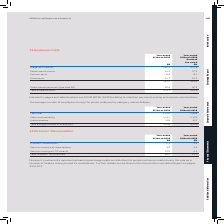According to Sophos Group's financial document, What was included in wages and salaries? $4.2M (2018: $4.0M) relating to retention payments arising on business combinations. The document states: "Included in wages and salaries above are $4.2M (2018: $4.0M) relating to retention payments arising on business combinations...." Also, What was the total employee costs in 2019? According to the financial document, 370.1 (in millions). The relevant text states: "Total employee costs 370.1 361.9..." Also, What are the types of costs considered when calculating the total employee costs? The document contains multiple relevant values: Wages and salaries, Social security costs, Pension costs, Other costs, Share-based payments. From the document: "Pension costs 8.9 8.4 Wages and salaries 286.0 271.8 Other costs 12.7 12.1 Social security costs 25.6 27.3 Share-based payments (see note 29) 36.9 42...." Additionally, In which year was Total employee costs larger? According to the financial document, 2019. The relevant text states: "Year-ended 31 March 2019..." Also, can you calculate: What was the change in total employee costs in 2019 from 2018? Based on the calculation: 370.1-361.9, the result is 8.2 (in millions). This is based on the information: "Total employee costs 370.1 361.9 Total employee costs 370.1 361.9..." The key data points involved are: 361.9, 370.1. Also, can you calculate: What was the percentage change in total employee costs in 2019 from 2018? To answer this question, I need to perform calculations using the financial data. The calculation is: (370.1-361.9)/361.9, which equals 2.27 (percentage). This is based on the information: "Total employee costs 370.1 361.9 Total employee costs 370.1 361.9..." The key data points involved are: 361.9, 370.1. 